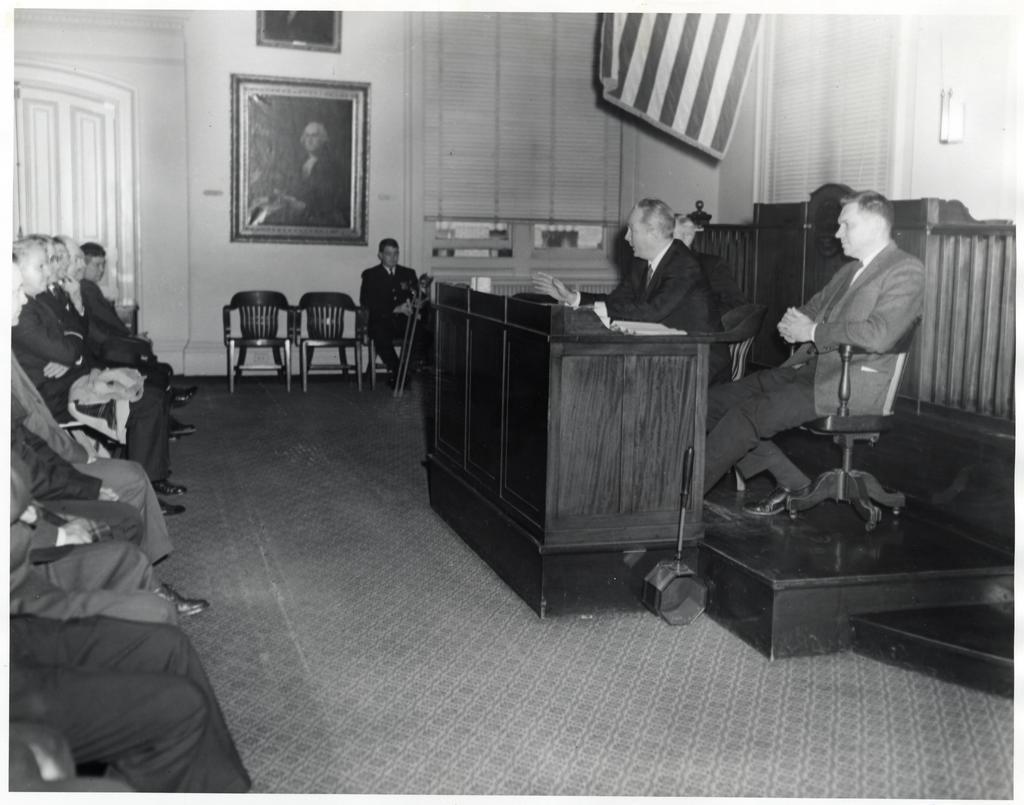How would you summarize this image in a sentence or two? In this picture there are some people those who are sitting at the left side of the image in a queue there is a portrait at the center of the image and there are two people those who are sitting on the stage and there is a desk in front of them, and there is a door at the left side of the image. 